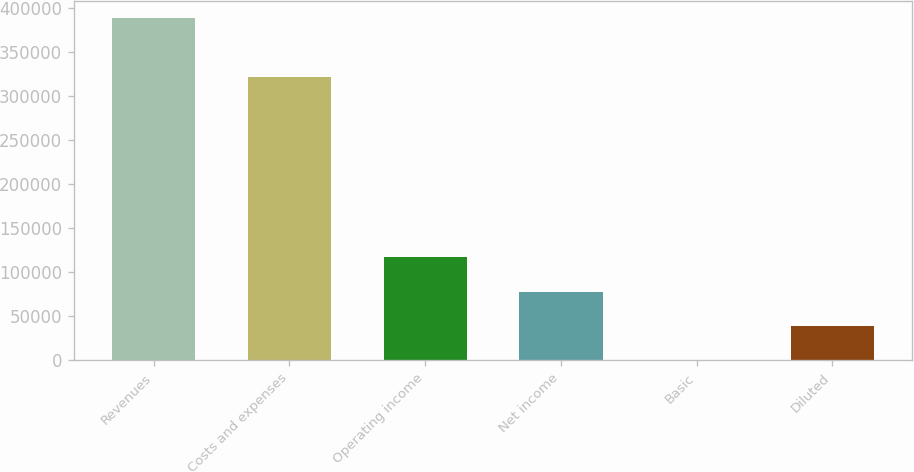Convert chart. <chart><loc_0><loc_0><loc_500><loc_500><bar_chart><fcel>Revenues<fcel>Costs and expenses<fcel>Operating income<fcel>Net income<fcel>Basic<fcel>Diluted<nl><fcel>388112<fcel>321021<fcel>116434<fcel>77622.6<fcel>0.21<fcel>38811.4<nl></chart> 